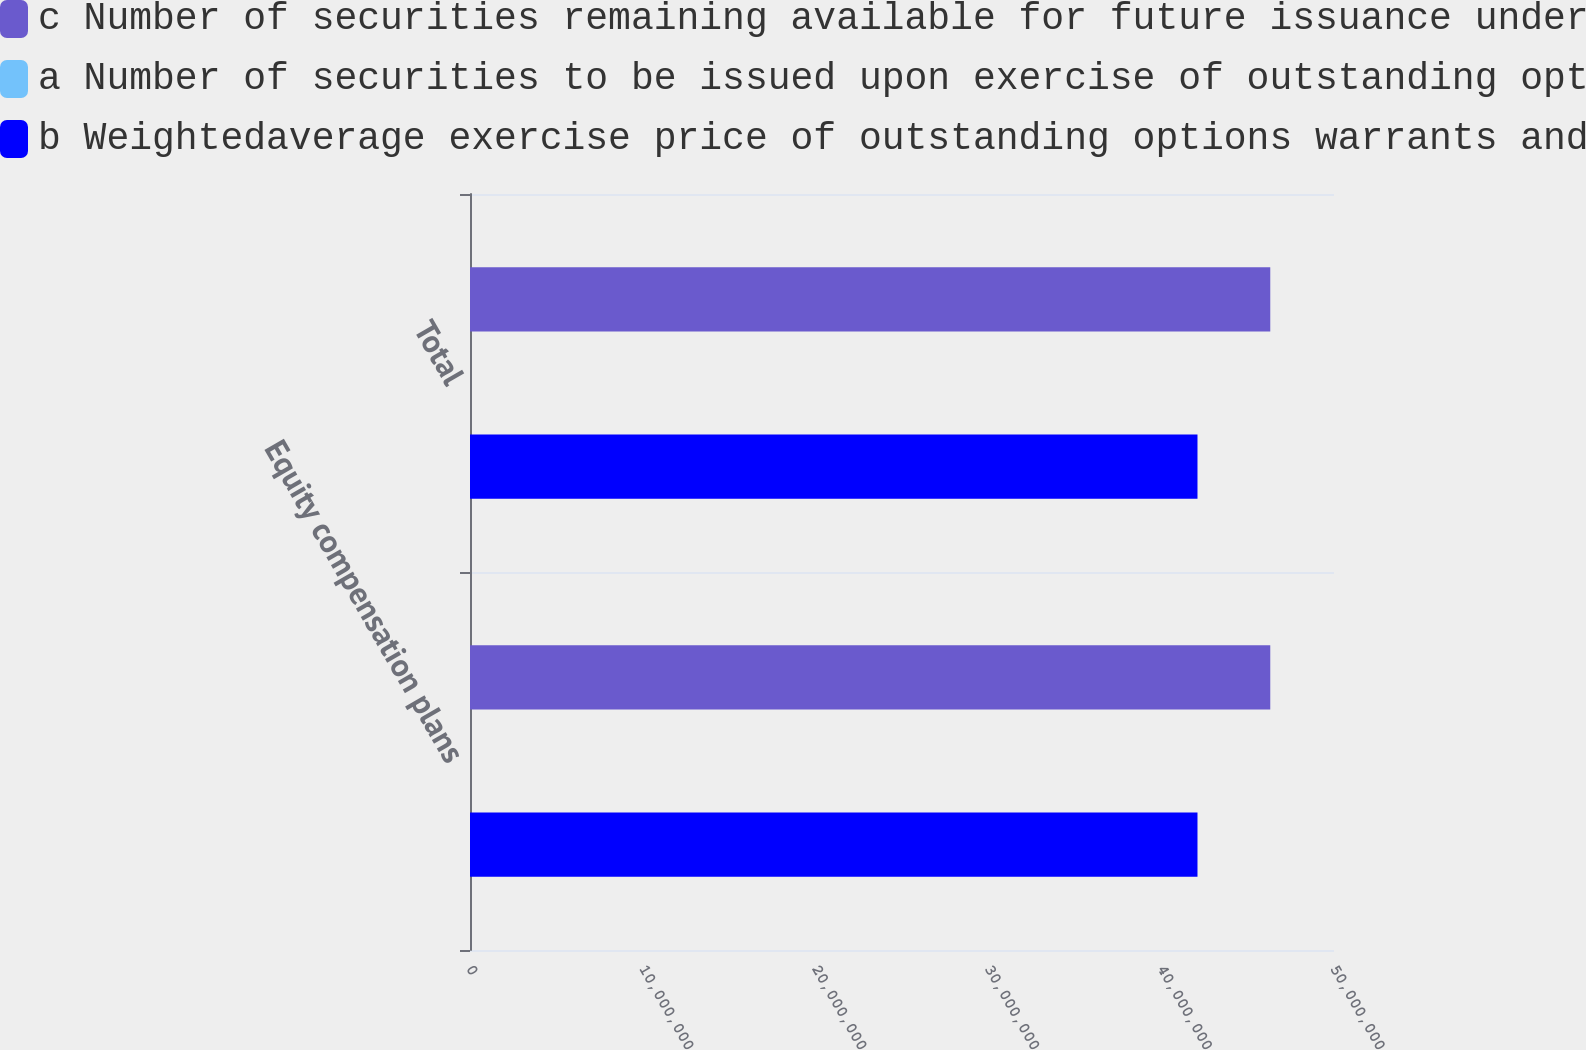Convert chart to OTSL. <chart><loc_0><loc_0><loc_500><loc_500><stacked_bar_chart><ecel><fcel>Equity compensation plans<fcel>Total<nl><fcel>c Number of securities remaining available for future issuance under equity compensation plans excluding securities reflected in columna<fcel>4.63118e+07<fcel>4.63118e+07<nl><fcel>a Number of securities to be issued upon exercise of outstanding options warrants and rights<fcel>9.26<fcel>9.26<nl><fcel>b Weightedaverage exercise price of outstanding options warrants and rights<fcel>4.20999e+07<fcel>4.20999e+07<nl></chart> 